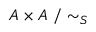Convert formula to latex. <formula><loc_0><loc_0><loc_500><loc_500>A \times A / \sim _ { S }</formula> 